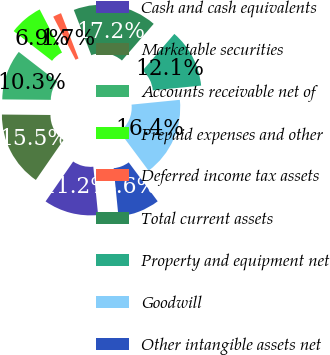<chart> <loc_0><loc_0><loc_500><loc_500><pie_chart><fcel>Cash and cash equivalents<fcel>Marketable securities<fcel>Accounts receivable net of<fcel>Prepaid expenses and other<fcel>Deferred income tax assets<fcel>Total current assets<fcel>Property and equipment net<fcel>Goodwill<fcel>Other intangible assets net<nl><fcel>11.21%<fcel>15.52%<fcel>10.35%<fcel>6.9%<fcel>1.73%<fcel>17.24%<fcel>12.07%<fcel>16.38%<fcel>8.62%<nl></chart> 